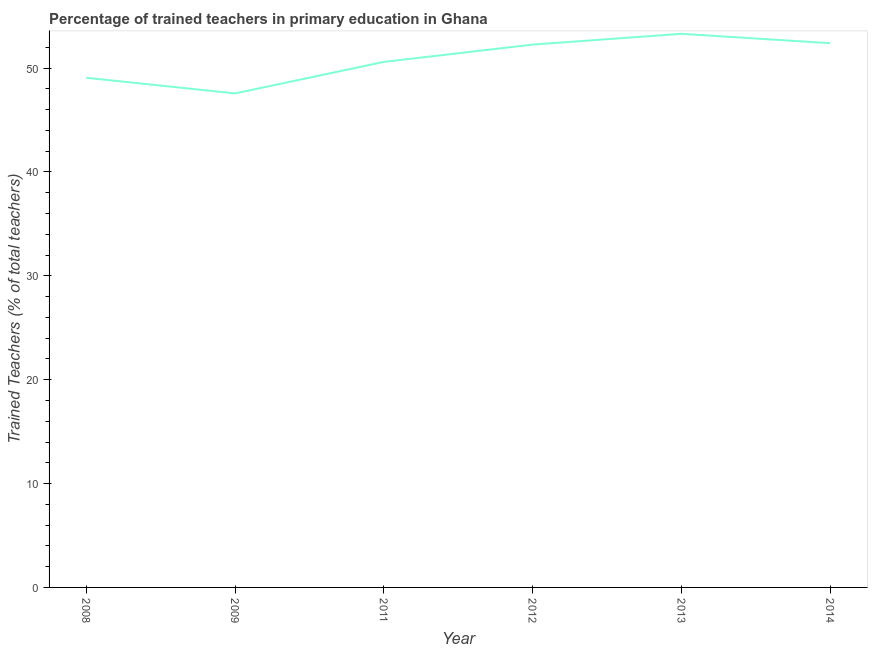What is the percentage of trained teachers in 2011?
Your answer should be very brief. 50.6. Across all years, what is the maximum percentage of trained teachers?
Your answer should be compact. 53.3. Across all years, what is the minimum percentage of trained teachers?
Your answer should be compact. 47.57. What is the sum of the percentage of trained teachers?
Offer a terse response. 305.21. What is the difference between the percentage of trained teachers in 2011 and 2014?
Offer a very short reply. -1.8. What is the average percentage of trained teachers per year?
Make the answer very short. 50.87. What is the median percentage of trained teachers?
Ensure brevity in your answer.  51.43. In how many years, is the percentage of trained teachers greater than 26 %?
Keep it short and to the point. 6. What is the ratio of the percentage of trained teachers in 2012 to that in 2014?
Provide a succinct answer. 1. Is the percentage of trained teachers in 2009 less than that in 2013?
Your response must be concise. Yes. Is the difference between the percentage of trained teachers in 2008 and 2011 greater than the difference between any two years?
Offer a very short reply. No. What is the difference between the highest and the second highest percentage of trained teachers?
Make the answer very short. 0.91. What is the difference between the highest and the lowest percentage of trained teachers?
Your answer should be compact. 5.74. In how many years, is the percentage of trained teachers greater than the average percentage of trained teachers taken over all years?
Provide a succinct answer. 3. Does the percentage of trained teachers monotonically increase over the years?
Make the answer very short. No. How many lines are there?
Your answer should be very brief. 1. How many years are there in the graph?
Provide a short and direct response. 6. What is the difference between two consecutive major ticks on the Y-axis?
Provide a short and direct response. 10. Does the graph contain grids?
Your answer should be very brief. No. What is the title of the graph?
Your response must be concise. Percentage of trained teachers in primary education in Ghana. What is the label or title of the X-axis?
Your answer should be very brief. Year. What is the label or title of the Y-axis?
Make the answer very short. Trained Teachers (% of total teachers). What is the Trained Teachers (% of total teachers) in 2008?
Provide a succinct answer. 49.07. What is the Trained Teachers (% of total teachers) in 2009?
Your answer should be compact. 47.57. What is the Trained Teachers (% of total teachers) in 2011?
Offer a very short reply. 50.6. What is the Trained Teachers (% of total teachers) of 2012?
Give a very brief answer. 52.27. What is the Trained Teachers (% of total teachers) of 2013?
Ensure brevity in your answer.  53.3. What is the Trained Teachers (% of total teachers) of 2014?
Your response must be concise. 52.4. What is the difference between the Trained Teachers (% of total teachers) in 2008 and 2009?
Ensure brevity in your answer.  1.5. What is the difference between the Trained Teachers (% of total teachers) in 2008 and 2011?
Provide a succinct answer. -1.53. What is the difference between the Trained Teachers (% of total teachers) in 2008 and 2012?
Your answer should be very brief. -3.19. What is the difference between the Trained Teachers (% of total teachers) in 2008 and 2013?
Provide a succinct answer. -4.23. What is the difference between the Trained Teachers (% of total teachers) in 2008 and 2014?
Offer a very short reply. -3.33. What is the difference between the Trained Teachers (% of total teachers) in 2009 and 2011?
Make the answer very short. -3.03. What is the difference between the Trained Teachers (% of total teachers) in 2009 and 2012?
Offer a very short reply. -4.7. What is the difference between the Trained Teachers (% of total teachers) in 2009 and 2013?
Provide a short and direct response. -5.74. What is the difference between the Trained Teachers (% of total teachers) in 2009 and 2014?
Provide a succinct answer. -4.83. What is the difference between the Trained Teachers (% of total teachers) in 2011 and 2012?
Your answer should be very brief. -1.67. What is the difference between the Trained Teachers (% of total teachers) in 2011 and 2013?
Offer a terse response. -2.7. What is the difference between the Trained Teachers (% of total teachers) in 2011 and 2014?
Offer a terse response. -1.8. What is the difference between the Trained Teachers (% of total teachers) in 2012 and 2013?
Offer a terse response. -1.04. What is the difference between the Trained Teachers (% of total teachers) in 2012 and 2014?
Your response must be concise. -0.13. What is the difference between the Trained Teachers (% of total teachers) in 2013 and 2014?
Keep it short and to the point. 0.91. What is the ratio of the Trained Teachers (% of total teachers) in 2008 to that in 2009?
Provide a succinct answer. 1.03. What is the ratio of the Trained Teachers (% of total teachers) in 2008 to that in 2012?
Your answer should be compact. 0.94. What is the ratio of the Trained Teachers (% of total teachers) in 2008 to that in 2013?
Your response must be concise. 0.92. What is the ratio of the Trained Teachers (% of total teachers) in 2008 to that in 2014?
Ensure brevity in your answer.  0.94. What is the ratio of the Trained Teachers (% of total teachers) in 2009 to that in 2011?
Provide a short and direct response. 0.94. What is the ratio of the Trained Teachers (% of total teachers) in 2009 to that in 2012?
Offer a very short reply. 0.91. What is the ratio of the Trained Teachers (% of total teachers) in 2009 to that in 2013?
Provide a succinct answer. 0.89. What is the ratio of the Trained Teachers (% of total teachers) in 2009 to that in 2014?
Offer a very short reply. 0.91. What is the ratio of the Trained Teachers (% of total teachers) in 2011 to that in 2012?
Provide a short and direct response. 0.97. What is the ratio of the Trained Teachers (% of total teachers) in 2011 to that in 2013?
Provide a short and direct response. 0.95. What is the ratio of the Trained Teachers (% of total teachers) in 2011 to that in 2014?
Provide a succinct answer. 0.97. What is the ratio of the Trained Teachers (% of total teachers) in 2012 to that in 2014?
Your answer should be compact. 1. 